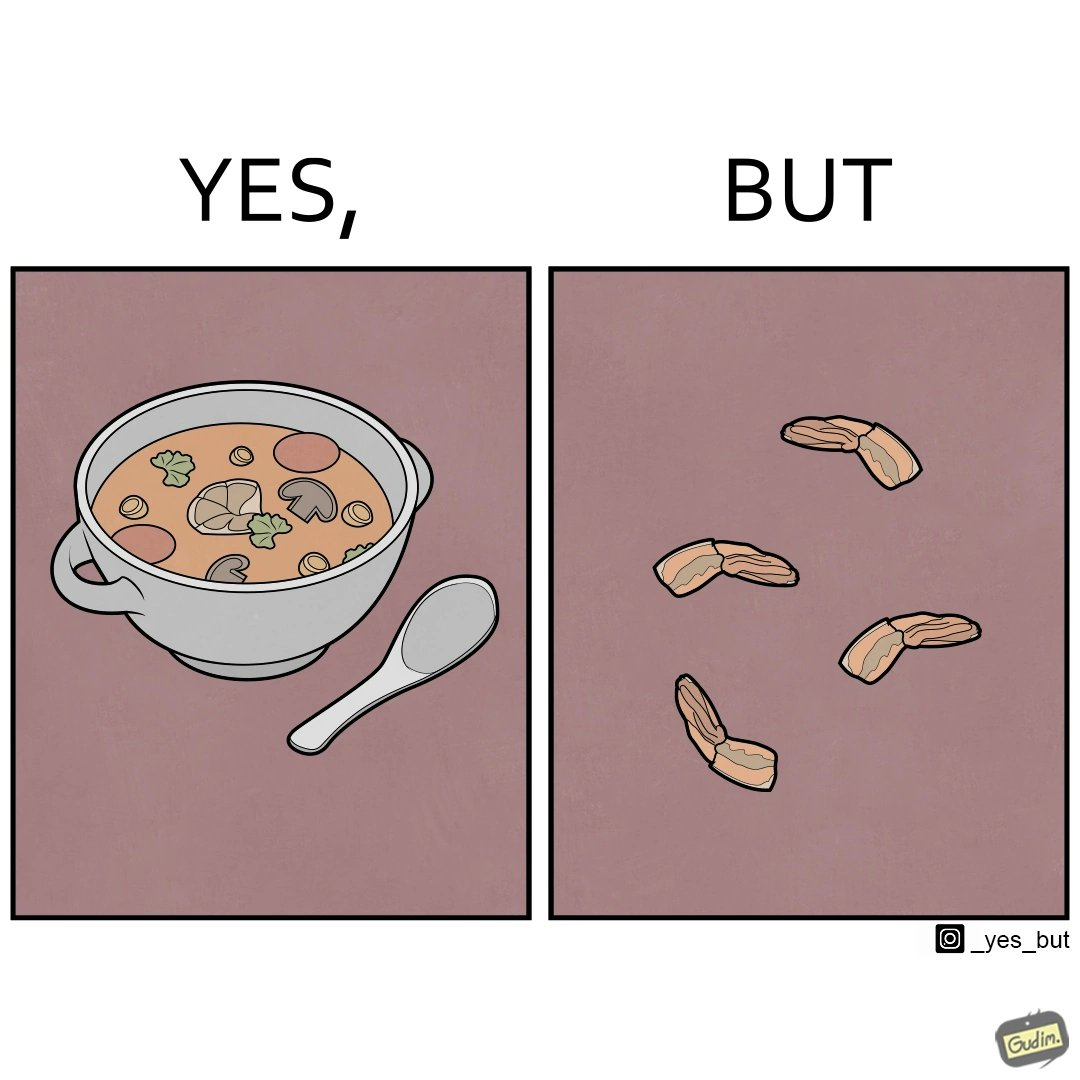Does this image contain satire or humor? Yes, this image is satirical. 